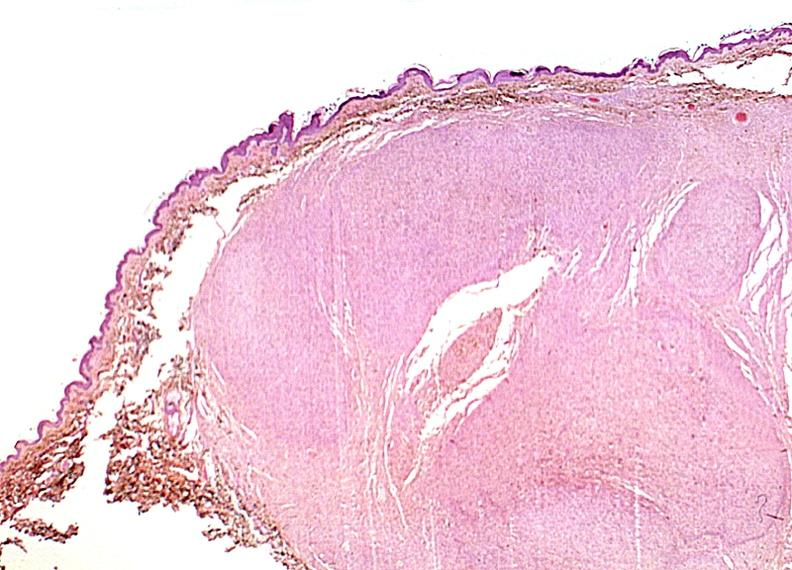where is this?
Answer the question using a single word or phrase. Skin 